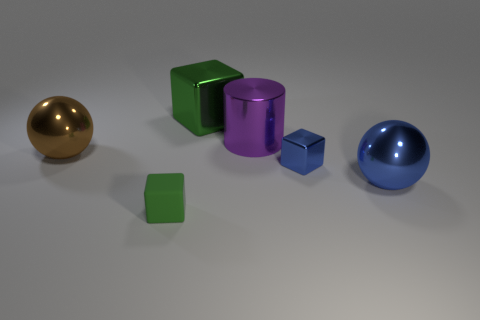Do the tiny matte block and the big block have the same color?
Your answer should be very brief. Yes. Are there any green matte objects that have the same shape as the tiny blue object?
Ensure brevity in your answer.  Yes. There is a thing that is on the right side of the tiny blue block; is it the same color as the small metallic cube?
Ensure brevity in your answer.  Yes. What shape is the large shiny thing that is the same color as the rubber thing?
Make the answer very short. Cube. What is the color of the tiny cube that is on the left side of the big green cube?
Make the answer very short. Green. What number of things are either cubes that are on the right side of the big cylinder or large yellow metal cylinders?
Give a very brief answer. 1. There is a cylinder that is the same size as the green shiny block; what color is it?
Your answer should be very brief. Purple. Is the number of tiny blocks to the right of the purple metallic cylinder greater than the number of small red metal spheres?
Your answer should be compact. Yes. There is a object that is to the right of the rubber object and in front of the blue metallic cube; what is it made of?
Offer a very short reply. Metal. There is a small block that is to the right of the big purple thing; does it have the same color as the large ball that is to the right of the tiny rubber thing?
Make the answer very short. Yes. 